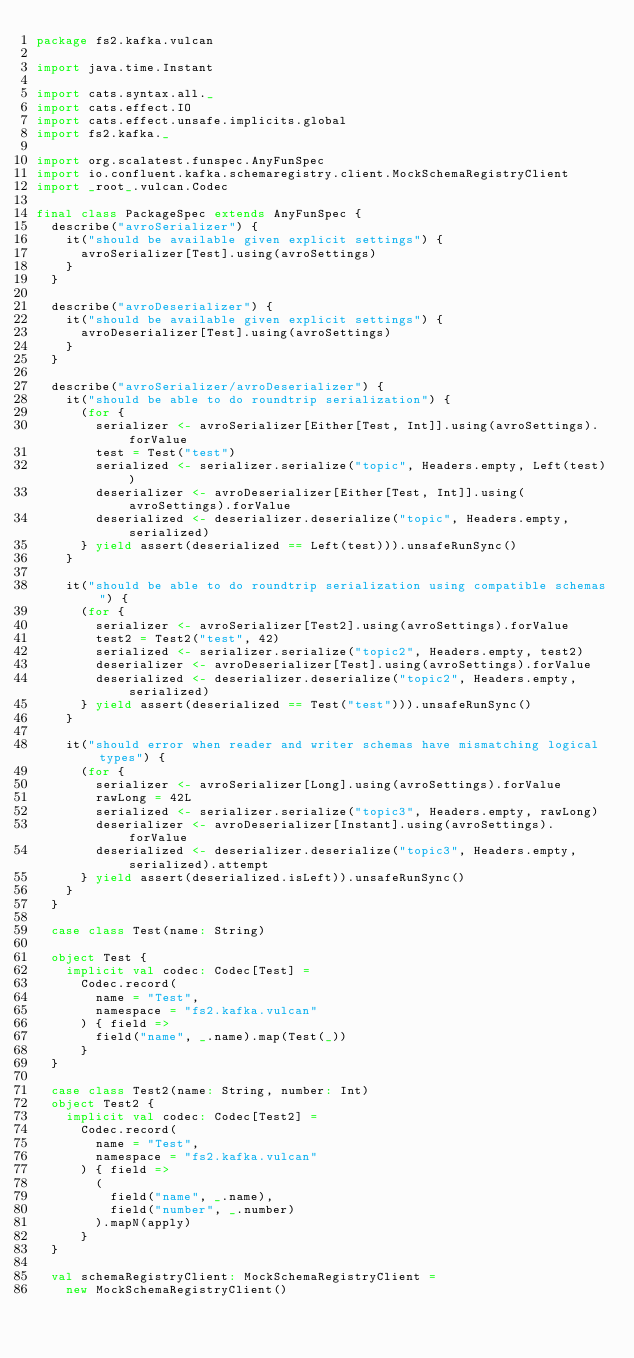<code> <loc_0><loc_0><loc_500><loc_500><_Scala_>package fs2.kafka.vulcan

import java.time.Instant

import cats.syntax.all._
import cats.effect.IO
import cats.effect.unsafe.implicits.global
import fs2.kafka._

import org.scalatest.funspec.AnyFunSpec
import io.confluent.kafka.schemaregistry.client.MockSchemaRegistryClient
import _root_.vulcan.Codec

final class PackageSpec extends AnyFunSpec {
  describe("avroSerializer") {
    it("should be available given explicit settings") {
      avroSerializer[Test].using(avroSettings)
    }
  }

  describe("avroDeserializer") {
    it("should be available given explicit settings") {
      avroDeserializer[Test].using(avroSettings)
    }
  }

  describe("avroSerializer/avroDeserializer") {
    it("should be able to do roundtrip serialization") {
      (for {
        serializer <- avroSerializer[Either[Test, Int]].using(avroSettings).forValue
        test = Test("test")
        serialized <- serializer.serialize("topic", Headers.empty, Left(test))
        deserializer <- avroDeserializer[Either[Test, Int]].using(avroSettings).forValue
        deserialized <- deserializer.deserialize("topic", Headers.empty, serialized)
      } yield assert(deserialized == Left(test))).unsafeRunSync()
    }

    it("should be able to do roundtrip serialization using compatible schemas") {
      (for {
        serializer <- avroSerializer[Test2].using(avroSettings).forValue
        test2 = Test2("test", 42)
        serialized <- serializer.serialize("topic2", Headers.empty, test2)
        deserializer <- avroDeserializer[Test].using(avroSettings).forValue
        deserialized <- deserializer.deserialize("topic2", Headers.empty, serialized)
      } yield assert(deserialized == Test("test"))).unsafeRunSync()
    }

    it("should error when reader and writer schemas have mismatching logical types") {
      (for {
        serializer <- avroSerializer[Long].using(avroSettings).forValue
        rawLong = 42L
        serialized <- serializer.serialize("topic3", Headers.empty, rawLong)
        deserializer <- avroDeserializer[Instant].using(avroSettings).forValue
        deserialized <- deserializer.deserialize("topic3", Headers.empty, serialized).attempt
      } yield assert(deserialized.isLeft)).unsafeRunSync()
    }
  }

  case class Test(name: String)

  object Test {
    implicit val codec: Codec[Test] =
      Codec.record(
        name = "Test",
        namespace = "fs2.kafka.vulcan"
      ) { field =>
        field("name", _.name).map(Test(_))
      }
  }

  case class Test2(name: String, number: Int)
  object Test2 {
    implicit val codec: Codec[Test2] =
      Codec.record(
        name = "Test",
        namespace = "fs2.kafka.vulcan"
      ) { field =>
        (
          field("name", _.name),
          field("number", _.number)
        ).mapN(apply)
      }
  }

  val schemaRegistryClient: MockSchemaRegistryClient =
    new MockSchemaRegistryClient()
</code> 